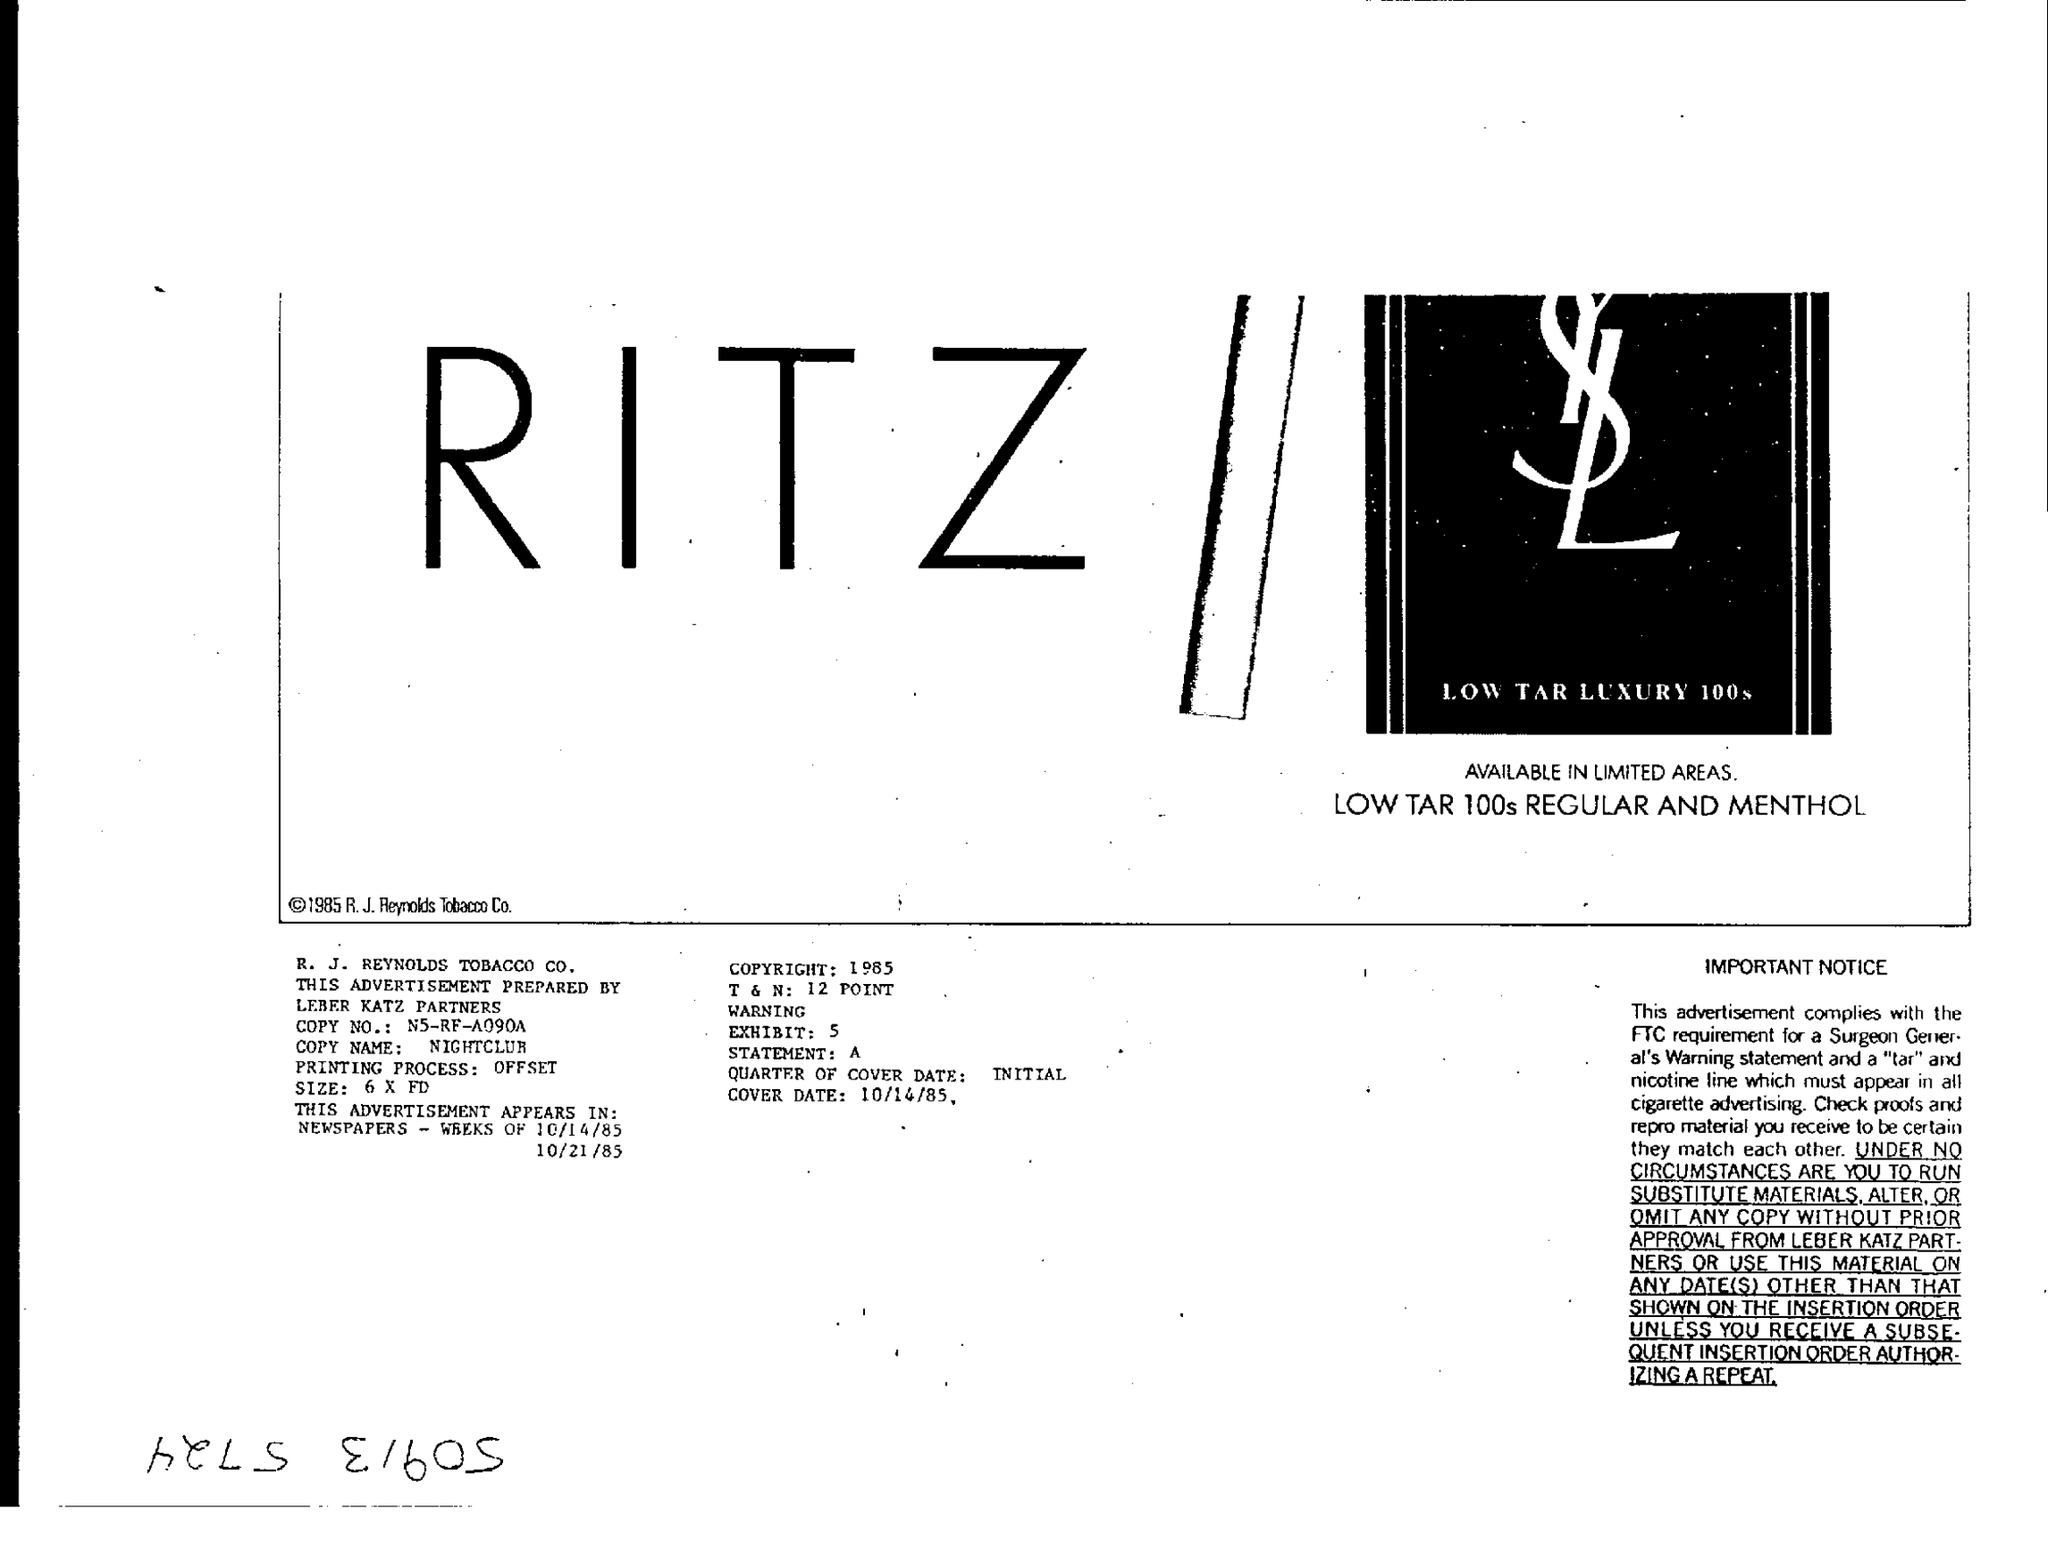Identify some key points in this picture. The text in large letters reads "RITZ." 